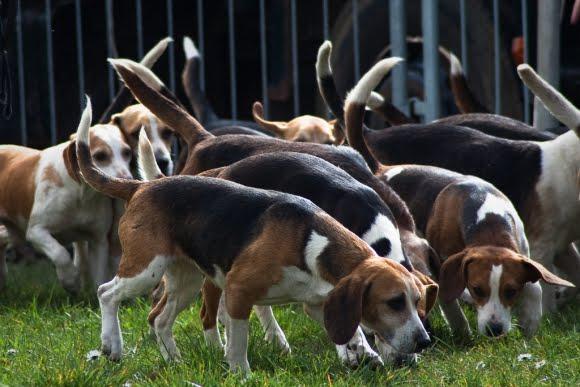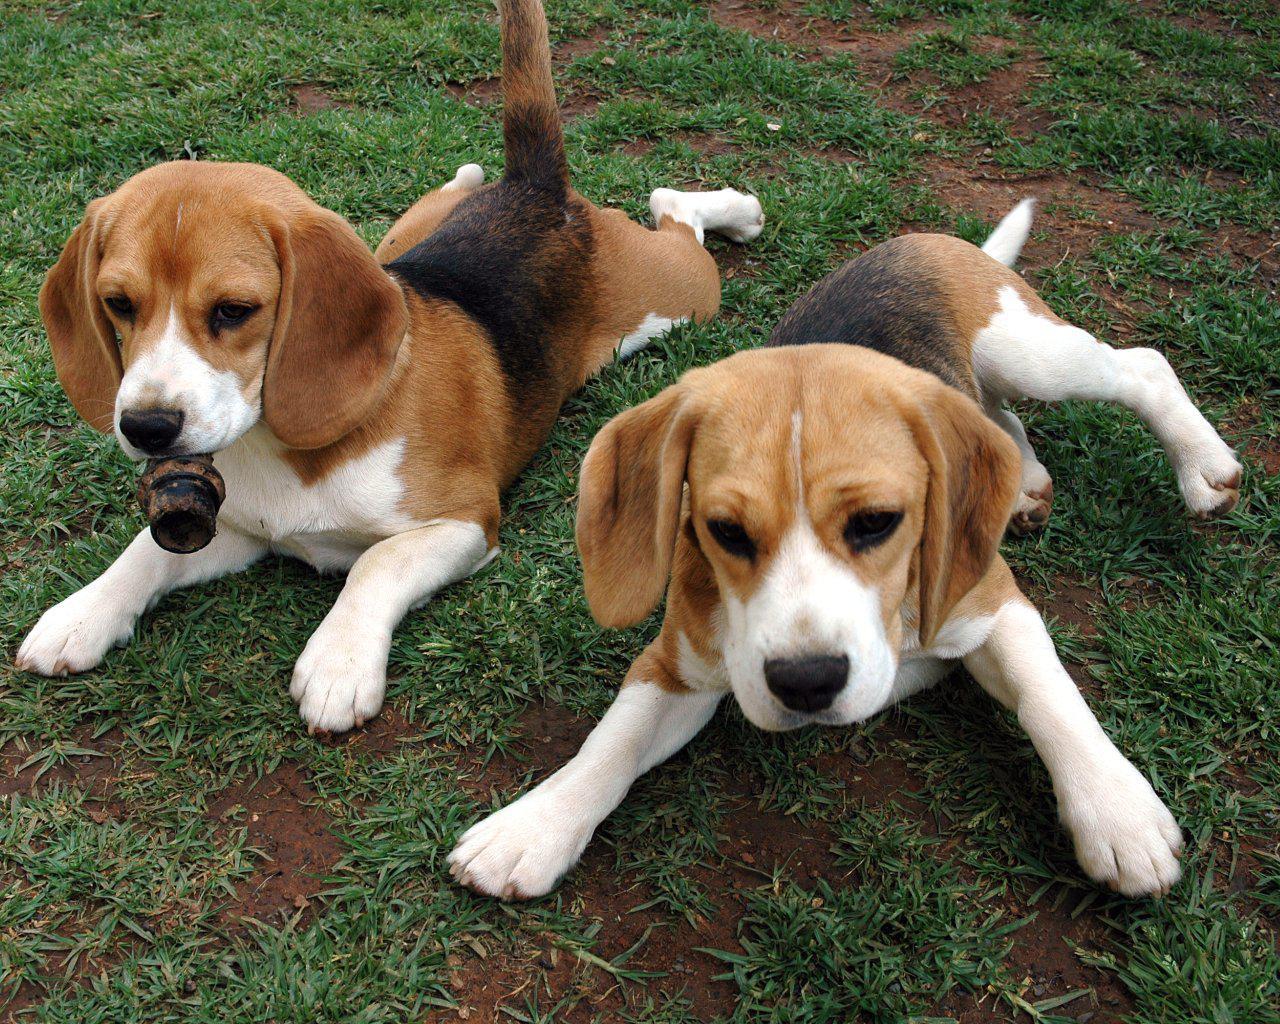The first image is the image on the left, the second image is the image on the right. Evaluate the accuracy of this statement regarding the images: "There are people near some of the dogs.". Is it true? Answer yes or no. No. The first image is the image on the left, the second image is the image on the right. Analyze the images presented: Is the assertion "One image contains exactly two animals, at least one of them a beagle." valid? Answer yes or no. Yes. The first image is the image on the left, the second image is the image on the right. For the images shown, is this caption "At least one human face is visible." true? Answer yes or no. No. The first image is the image on the left, the second image is the image on the right. Assess this claim about the two images: "Left image includes a person with a group of dogs.". Correct or not? Answer yes or no. No. 